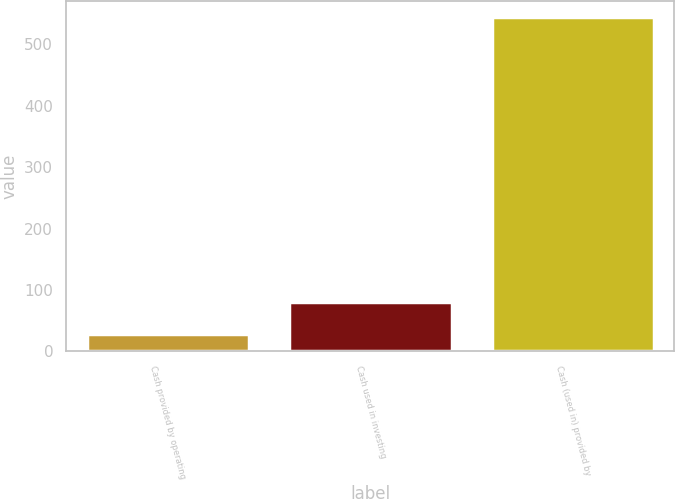Convert chart to OTSL. <chart><loc_0><loc_0><loc_500><loc_500><bar_chart><fcel>Cash provided by operating<fcel>Cash used in investing<fcel>Cash (used in) provided by<nl><fcel>29<fcel>80.5<fcel>544<nl></chart> 